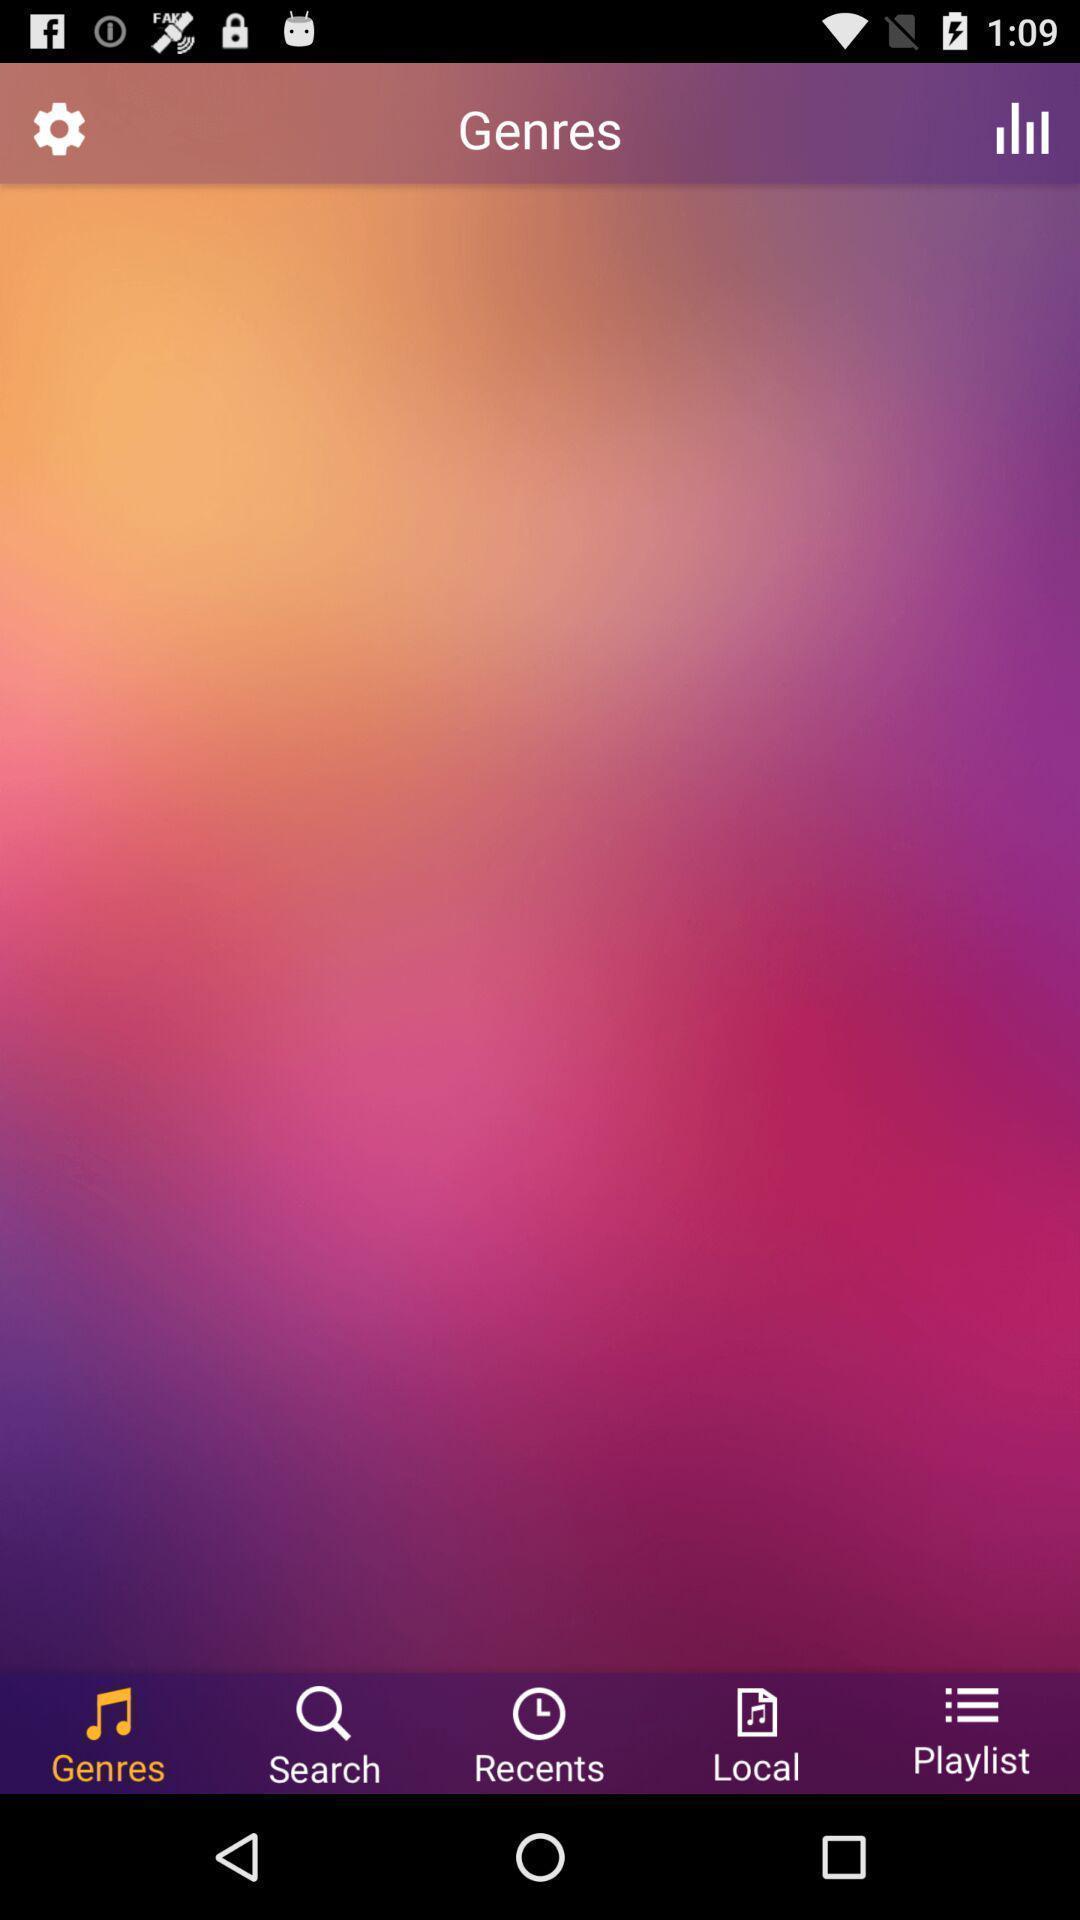Describe the content in this image. Page displaying genres along with other options in music application. 